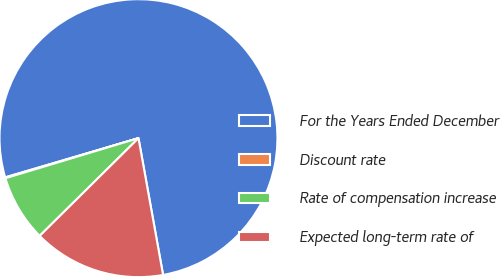Convert chart to OTSL. <chart><loc_0><loc_0><loc_500><loc_500><pie_chart><fcel>For the Years Ended December<fcel>Discount rate<fcel>Rate of compensation increase<fcel>Expected long-term rate of<nl><fcel>76.72%<fcel>0.1%<fcel>7.76%<fcel>15.42%<nl></chart> 